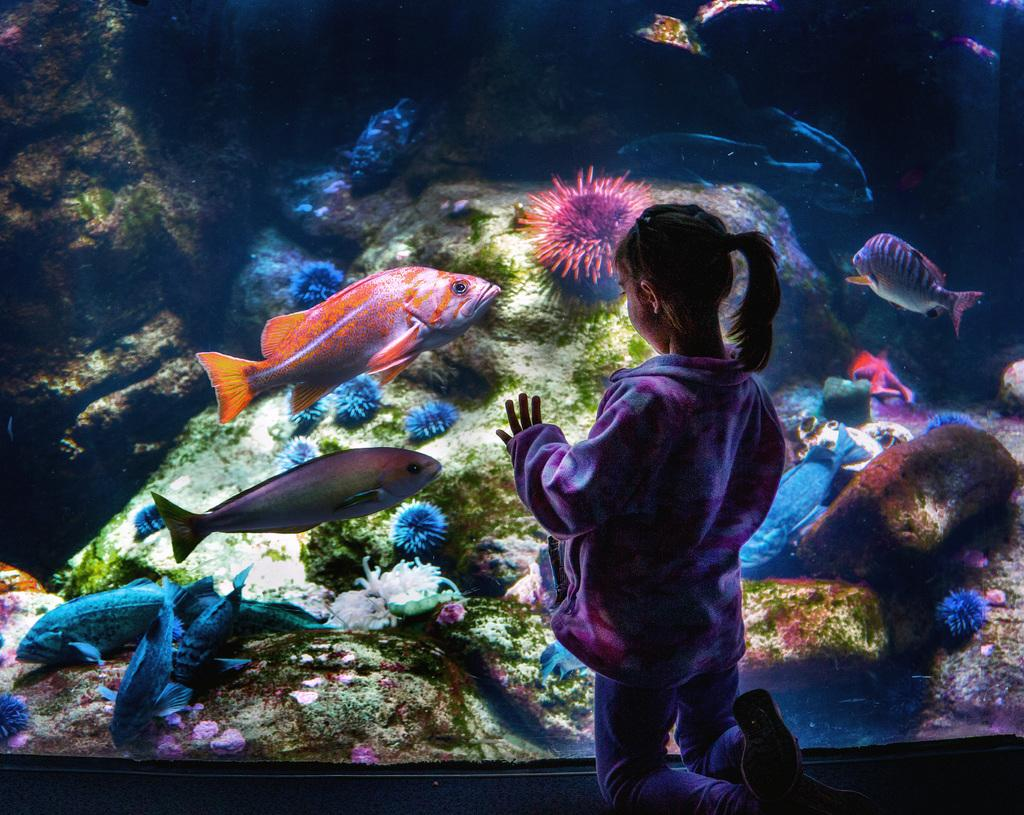Who is present in the image? There is a girl in the image. What is the girl standing near? The girl is standing near an aquarium. What can be seen inside the aquarium? There are fishes and plants in the aquarium. What is visible in the background of the image? In the background, there appears to be a rock. What type of finger can be seen in the image? There is no finger present in the image. What kind of vacation is the girl planning based on the image? The image does not provide any information about the girl's vacation plans. 